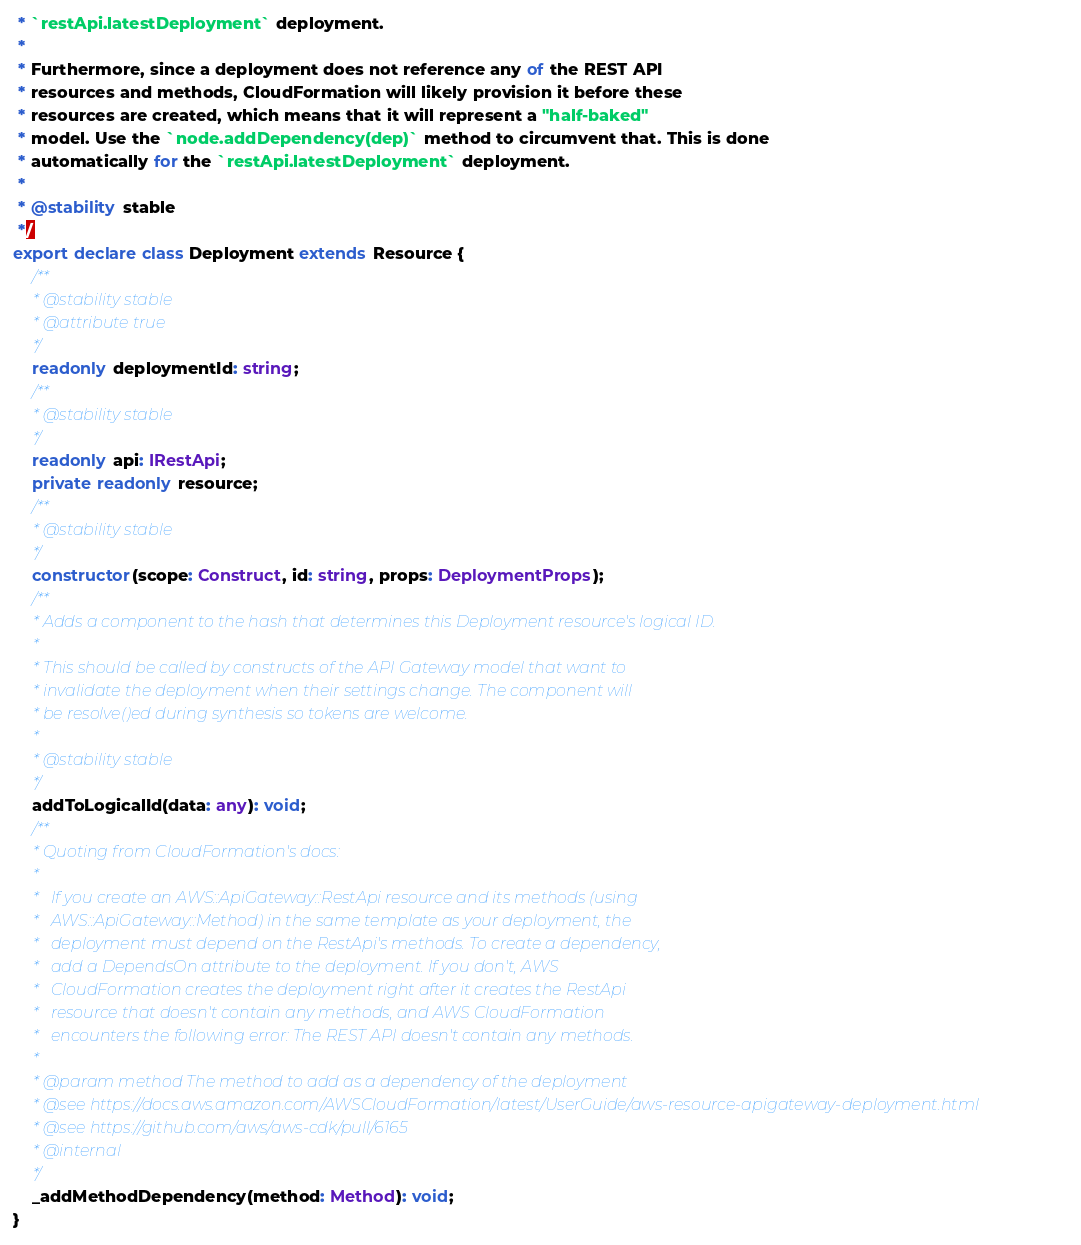Convert code to text. <code><loc_0><loc_0><loc_500><loc_500><_TypeScript_> * `restApi.latestDeployment` deployment.
 *
 * Furthermore, since a deployment does not reference any of the REST API
 * resources and methods, CloudFormation will likely provision it before these
 * resources are created, which means that it will represent a "half-baked"
 * model. Use the `node.addDependency(dep)` method to circumvent that. This is done
 * automatically for the `restApi.latestDeployment` deployment.
 *
 * @stability stable
 */
export declare class Deployment extends Resource {
    /**
     * @stability stable
     * @attribute true
     */
    readonly deploymentId: string;
    /**
     * @stability stable
     */
    readonly api: IRestApi;
    private readonly resource;
    /**
     * @stability stable
     */
    constructor(scope: Construct, id: string, props: DeploymentProps);
    /**
     * Adds a component to the hash that determines this Deployment resource's logical ID.
     *
     * This should be called by constructs of the API Gateway model that want to
     * invalidate the deployment when their settings change. The component will
     * be resolve()ed during synthesis so tokens are welcome.
     *
     * @stability stable
     */
    addToLogicalId(data: any): void;
    /**
     * Quoting from CloudFormation's docs:
     *
     *   If you create an AWS::ApiGateway::RestApi resource and its methods (using
     *   AWS::ApiGateway::Method) in the same template as your deployment, the
     *   deployment must depend on the RestApi's methods. To create a dependency,
     *   add a DependsOn attribute to the deployment. If you don't, AWS
     *   CloudFormation creates the deployment right after it creates the RestApi
     *   resource that doesn't contain any methods, and AWS CloudFormation
     *   encounters the following error: The REST API doesn't contain any methods.
     *
     * @param method The method to add as a dependency of the deployment
     * @see https://docs.aws.amazon.com/AWSCloudFormation/latest/UserGuide/aws-resource-apigateway-deployment.html
     * @see https://github.com/aws/aws-cdk/pull/6165
     * @internal
     */
    _addMethodDependency(method: Method): void;
}
</code> 